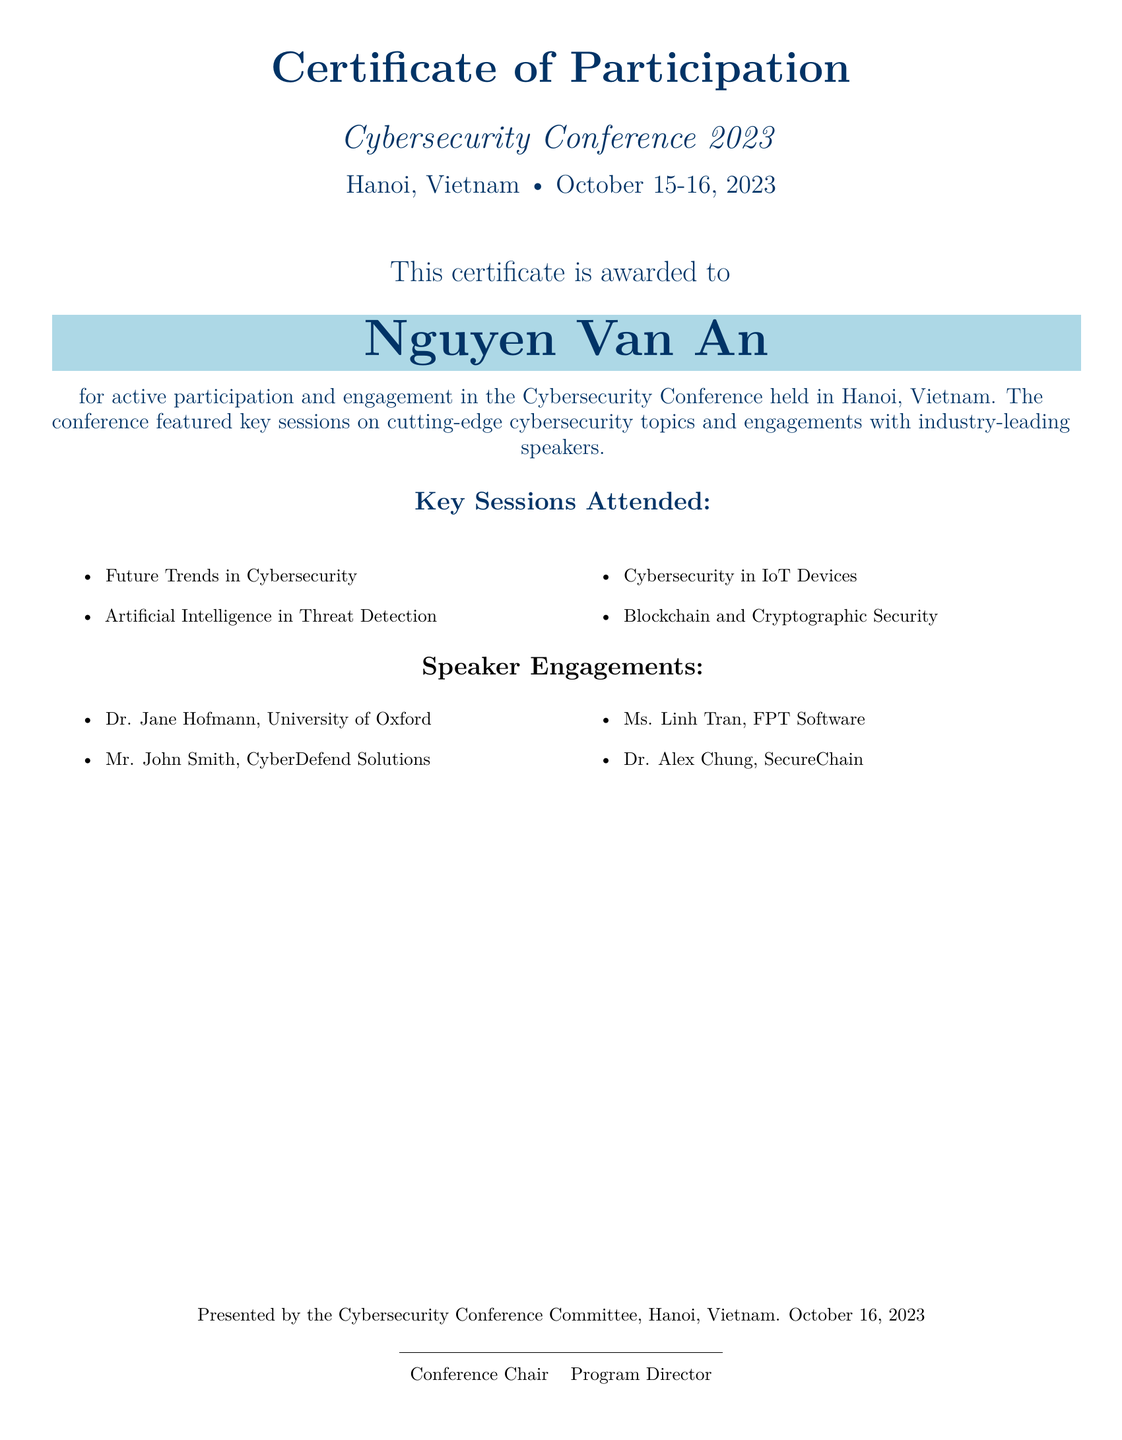What is the name of the participant? The participant's name is highlighted in the document as the certificate holder.
Answer: Nguyen Van An What is the location of the Cybersecurity Conference 2023? The document specifies the conference's venue within its title and date section.
Answer: Hanoi, Vietnam When was the Cybersecurity Conference held? The dates are clearly listed at the beginning of the document.
Answer: October 15-16, 2023 What is one key session attended? The document lists several key sessions attended, showcasing topics in cybersecurity.
Answer: Future Trends in Cybersecurity Who is one of the speakers at the conference? The document mentions several speakers under the 'Speaker Engagements' section.
Answer: Dr. Jane Hofmann How many key sessions are listed in the document? The document enumerates the number of sessions in the relevant section.
Answer: Four What is the title of the certificate? The title of the certificate is displayed prominently at the top of the document.
Answer: Certificate of Participation Who presented the certificate? The document indicates the presenting body clearly towards the end.
Answer: Cybersecurity Conference Committee What is the role of the person who signed as Conference Chair? The title of the individual in the document provides the nature of their responsibility.
Answer: Conference Chair 